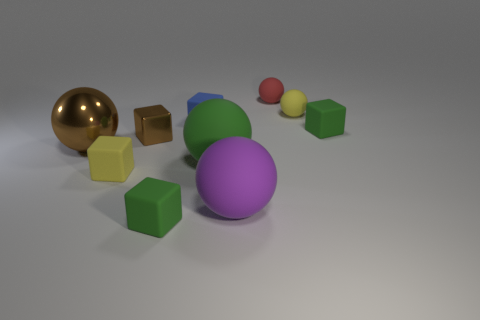What number of cylinders are either green objects or small red rubber objects?
Keep it short and to the point. 0. What is the size of the yellow matte object that is to the right of the green block in front of the large matte sphere left of the big purple matte object?
Make the answer very short. Small. Are there any tiny objects in front of the red matte ball?
Your answer should be compact. Yes. There is a object that is the same color as the small metal cube; what is its shape?
Your answer should be very brief. Sphere. What number of objects are either green rubber things to the left of the small red object or metallic objects?
Your answer should be compact. 4. What size is the blue thing that is the same material as the tiny yellow block?
Make the answer very short. Small. Do the brown shiny ball and the block in front of the large purple object have the same size?
Your answer should be very brief. No. There is a small rubber thing that is both behind the big purple sphere and in front of the large green thing; what color is it?
Provide a short and direct response. Yellow. What number of things are shiny things that are right of the small yellow block or green matte blocks that are right of the blue cube?
Give a very brief answer. 2. The small rubber block that is to the left of the tiny green rubber block in front of the tiny green thing behind the tiny brown metal object is what color?
Your answer should be compact. Yellow. 